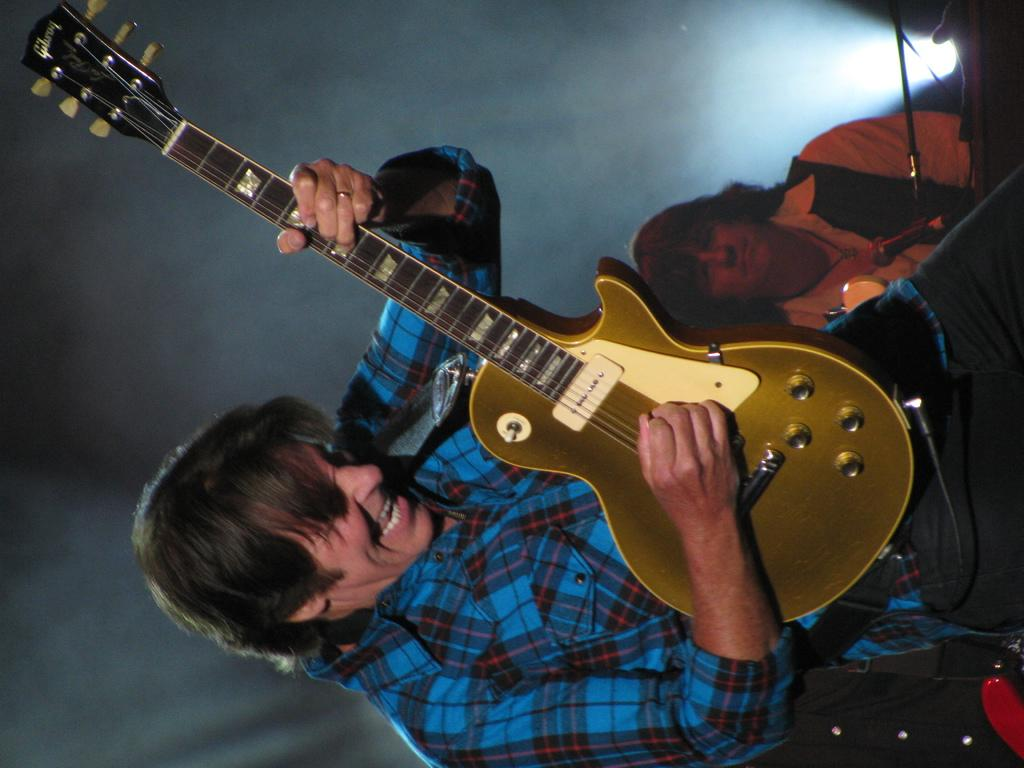What is the person in the image doing with the book? The person is holding a book and reading it. What can be seen in the background of the image? There is a table and a chair in the background of the image. How many people are present in the image? There is only one person present in the image. What type of bread is being served at the plot of land in the image? There is no plot of land or bread present in the image; it features a person holding and reading a book with a table and chair in the background. 